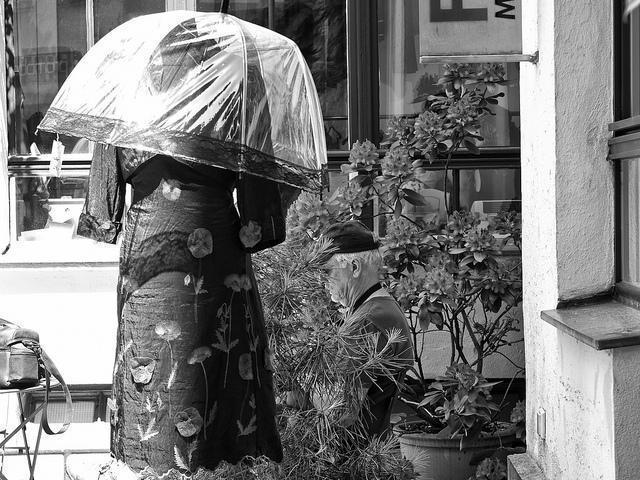Why no hands or head?
Indicate the correct choice and explain in the format: 'Answer: answer
Rationale: rationale.'
Options: Cut off, small limbs, is mannequin, under dress. Answer: is mannequin.
Rationale: Not a person 